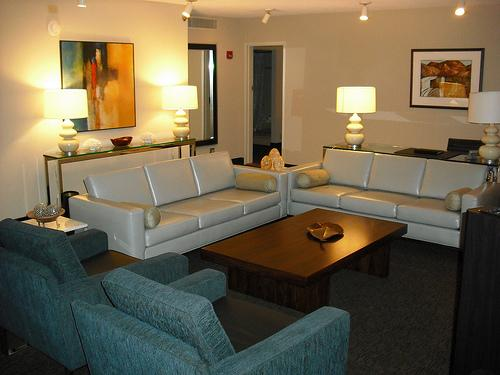Mention the special features of the art piece and mirror on the wall. The art piece has a black frame, and the mirror has a black trim. Identify the main furniture present in the image. The main furniture in the image includes a white three-seated couch, two blue chairs, a wooden coffee table, and a leather sofa. Give a brief description of the table in the middle of the room. There is a wooden table in the middle of the room with a tray and a red bowl on it. Analyze the overall sentiment of the living room atmosphere. The living room atmosphere gives a cozy, comfortable, and welcoming sentiment. Provide some details about the wall decorations in the image. The wall decorations include a black trimmed hung mirror, a black framed art piece, a picture in a frame, and a mirror on the wall. Can you tell me about the color theme of the living room? The living room is white and blue in color theme. How many lamps are present in this living room scene? There are a total of four white lamps in the living room. How many lights are turned on in the room? There are seven glowing lights in the room. Count the number of couch cushions in the room. There are three couch cushions in the room. List the various items placed on the wooden coffee table. There is a tray, a red bowl, a plate, and a pillow on the wooden coffee table. How many lights are glowing in the room? Seven What is the state of the lamp in the room? The lamp is on. Which object is seen on the wooden coffee table? A tray Is there any seating other than the sofa in the living room? Yes, two blue chairs are present. Is there any art displayed in the living room? If so, provide an example. Yes, a black framed art piece on the wall. Count the number of couch cushions visible in the room. Three Explain the layout and design of the living room. A white and blue living room with a white three-seated couch, two blue chairs, wooden coffee table, lamps, and various decorations. Identify the color and type of sofa in the living room. White three-seated couch What color are the walls in the living room? White What is the color of the bowl on the table? Red What type of table is featured prominently in the living room? A wooden coffee table What position is a black framed art piece in the room? On the wall What type of table is in the middle of the room? A wooden table Are there any lights on the ceiling in the room? Yes, there are five lights on the ceiling. Confirm the presence of a stand behind the couch. Yes, there is a stand behind the couch. Name one of the decorations on the end table. A lamp Describe the color and style of the living room. White and blue Can you find a fixture on the table? Yes, there is a fixture on the table. Choose the best description for the object hanging on the wall next to the mirror. A picture in a frame What specific color are the chairs in the room? Blue 